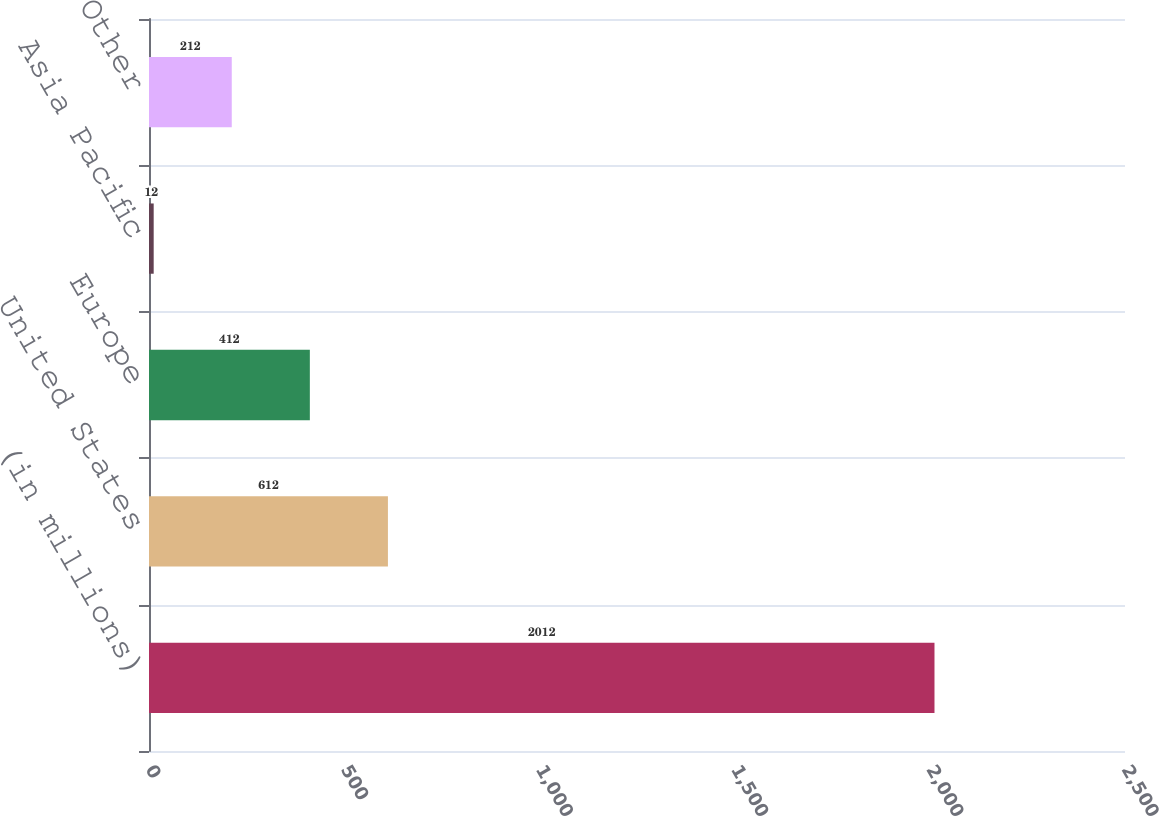<chart> <loc_0><loc_0><loc_500><loc_500><bar_chart><fcel>(in millions)<fcel>United States<fcel>Europe<fcel>Asia Pacific<fcel>Other<nl><fcel>2012<fcel>612<fcel>412<fcel>12<fcel>212<nl></chart> 